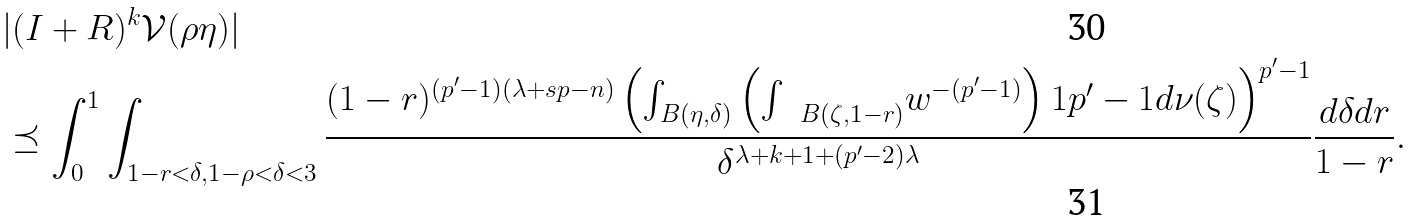Convert formula to latex. <formula><loc_0><loc_0><loc_500><loc_500>& | ( I + R ) ^ { k } { \mathcal { V } } ( \rho \eta ) | \\ & \preceq \int _ { 0 } ^ { 1 } \int _ { 1 - r < \delta , 1 - \rho < \delta < 3 } \frac { ( 1 - r ) ^ { ( p ^ { \prime } - 1 ) ( \lambda + s p - n ) } \left ( \int _ { B ( \eta , \delta ) } \left ( { \int \, \ } _ { B ( \zeta , 1 - r ) } w ^ { - ( p ^ { \prime } - 1 ) } \right ) ^ { } { 1 } { p ^ { \prime } - 1 } d \nu ( \zeta ) \right ) ^ { p ^ { \prime } - 1 } } { \delta ^ { \lambda + k + 1 + ( p ^ { \prime } - 2 ) \lambda } } \frac { d \delta d r } { 1 - r } .</formula> 